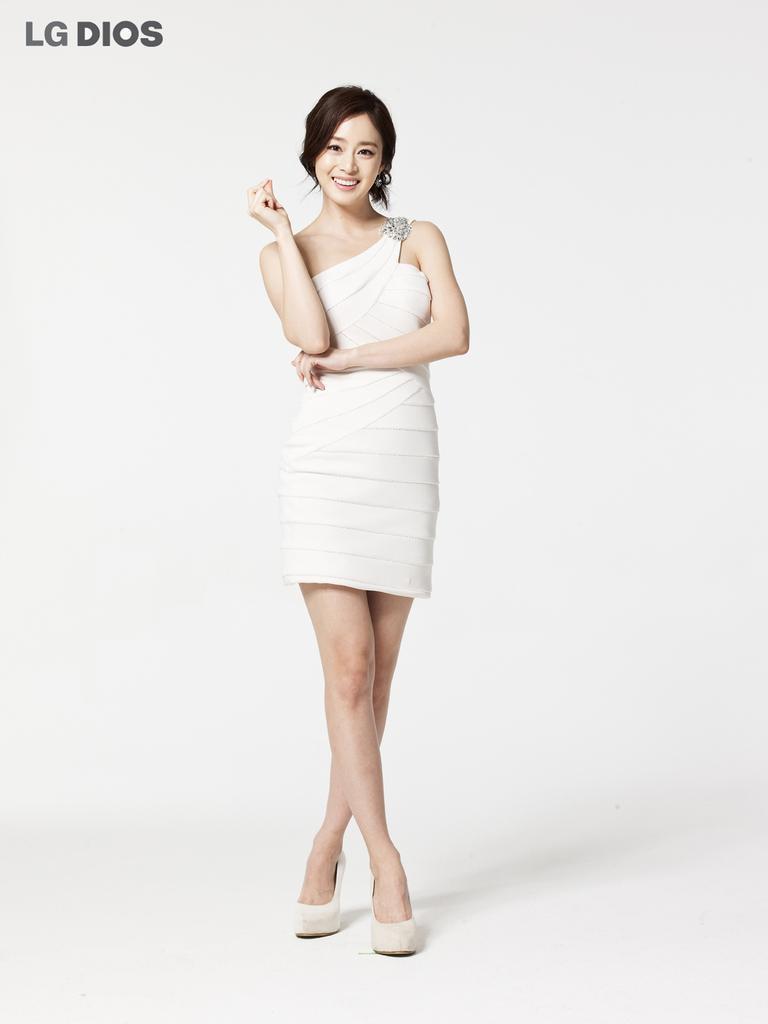Can you describe this image briefly? In the center of the picture there is a woman wearing a white dress, she is smiling. The background is white. At the top left there is text. 